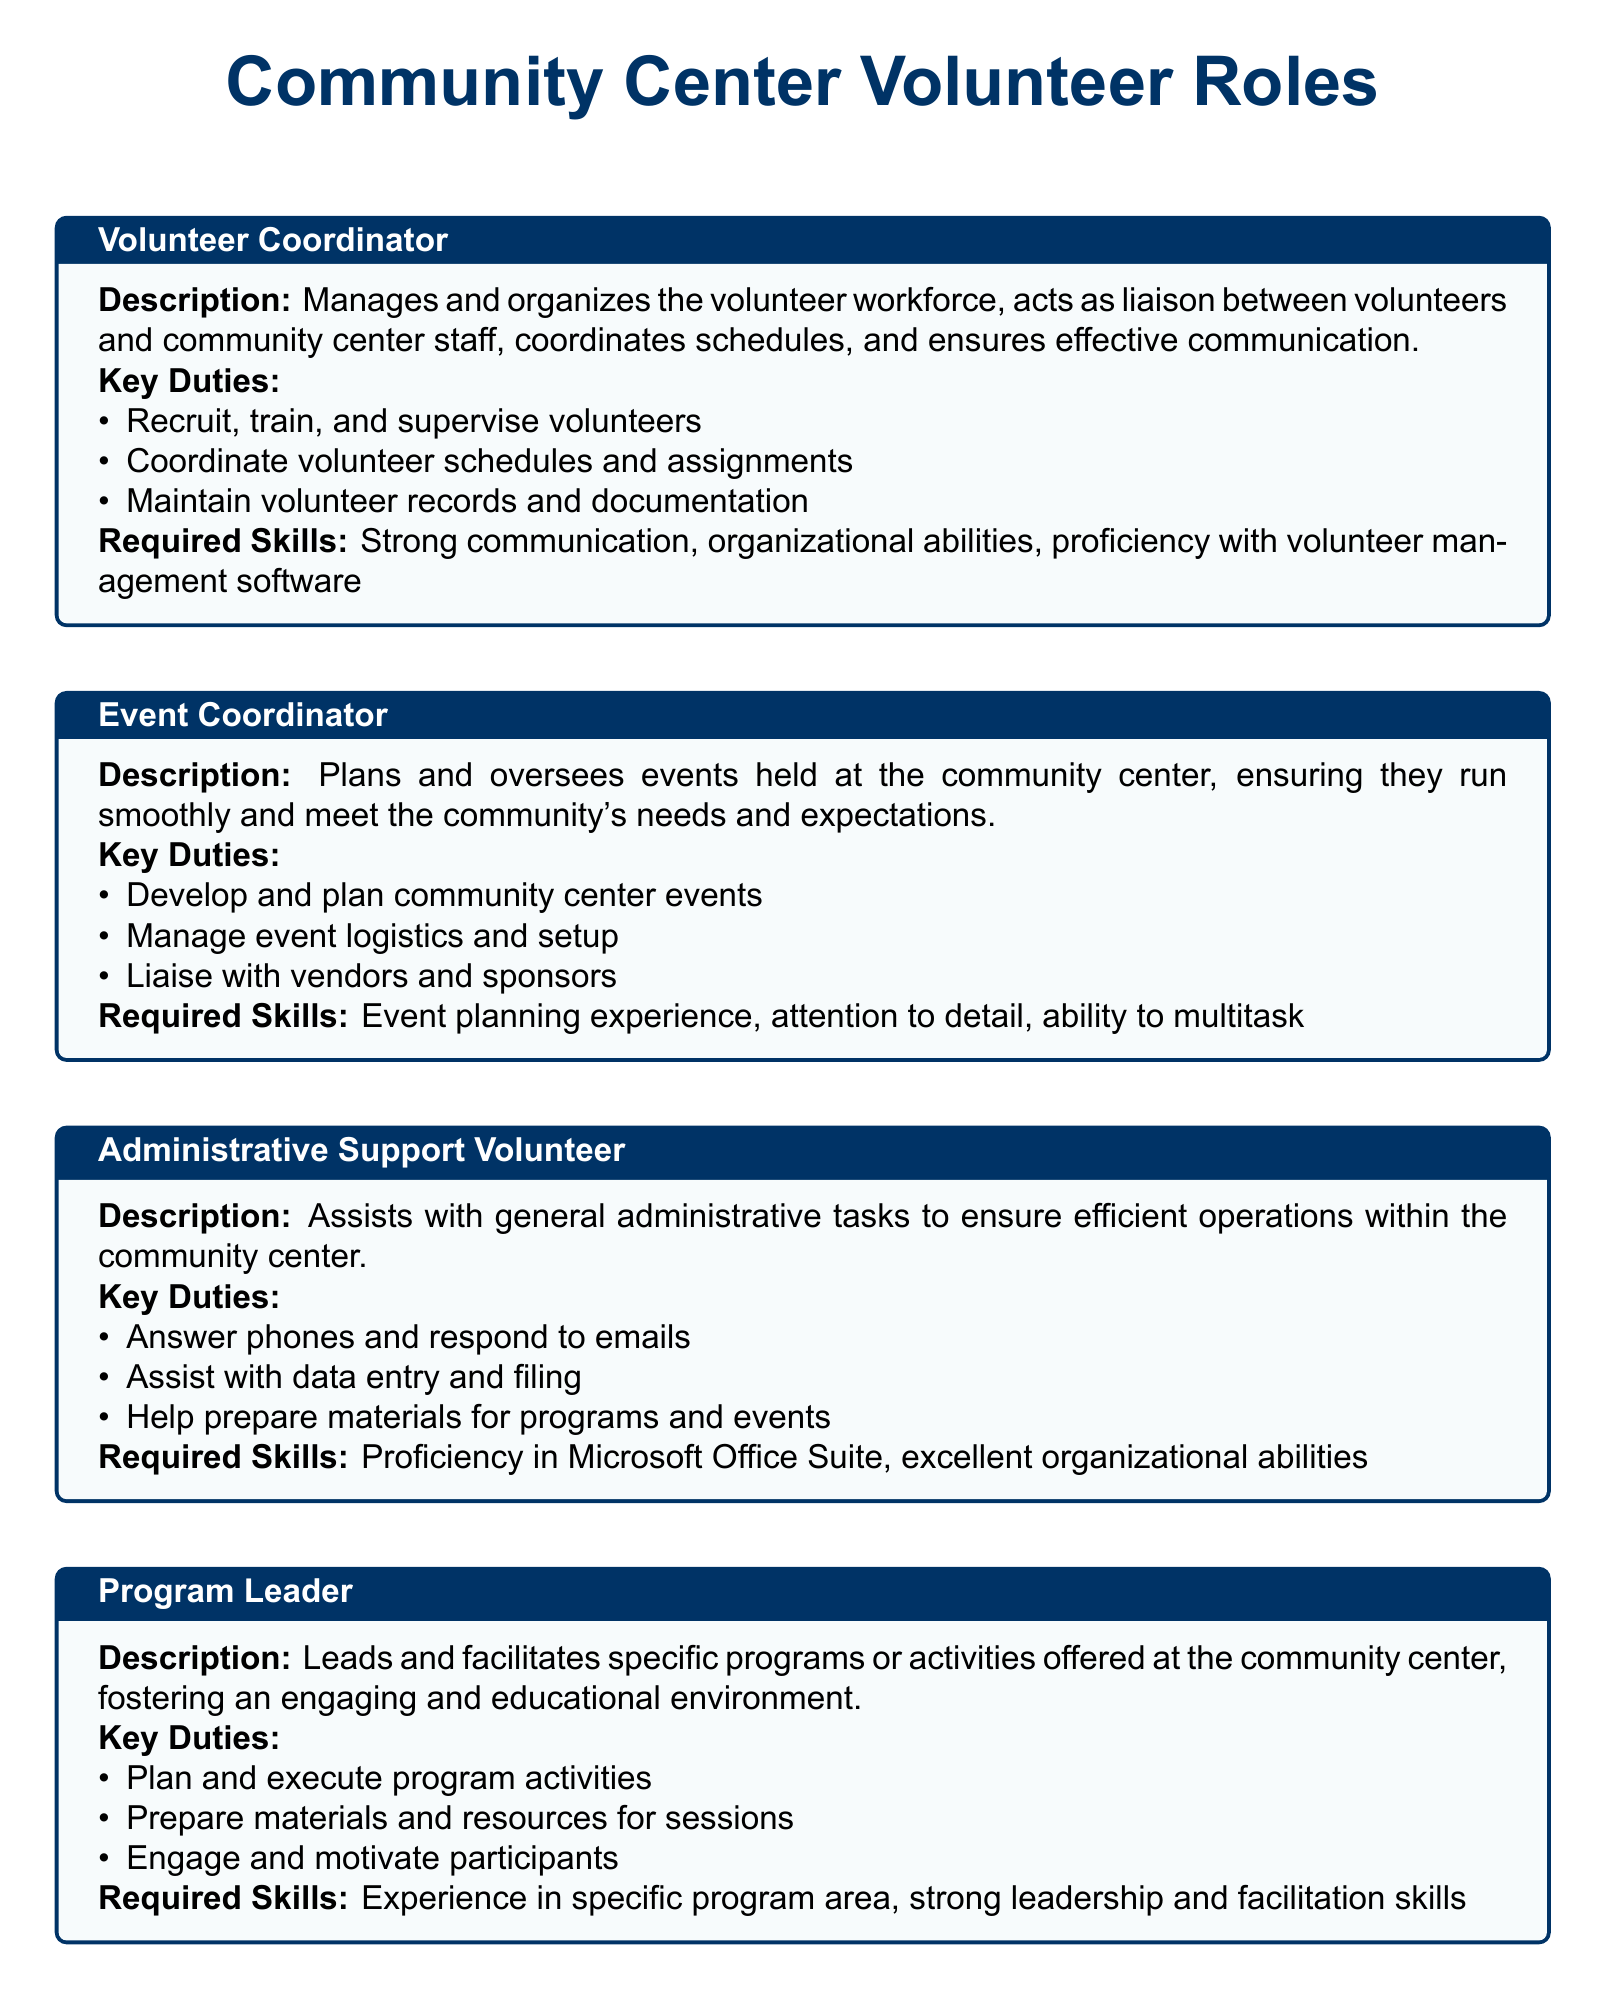what is the title of the document? The title of the document is stated at the top as "Community Center Volunteer Roles."
Answer: Community Center Volunteer Roles who is responsible for managing the volunteer workforce? The document specifies that the Volunteer Coordinator manages the volunteer workforce.
Answer: Volunteer Coordinator how many key duties are listed for an Event Coordinator? The Event Coordinator has three key duties outlined in the document.
Answer: 3 what are the required skills for an Administrative Support Volunteer? The required skills for an Administrative Support Volunteer include proficiency in Microsoft Office Suite and excellent organizational abilities.
Answer: Proficiency in Microsoft Office Suite, excellent organizational abilities which role is responsible for maintaining the cleanliness of the community center? The role that helps maintain the cleanliness and functionality of the community center facilities is the Facilities Maintenance Volunteer.
Answer: Facilities Maintenance Volunteer which volunteer role involves liaising with vendors? The Event Coordinator is the volunteer role that involves liaising with vendors and sponsors.
Answer: Event Coordinator what is one of the required skills for a Program Leader? A required skill for a Program Leader is strong leadership and facilitation skills.
Answer: Strong leadership and facilitation skills how does the Volunteer Coordinator assist volunteers? The Volunteer Coordinator recruits, trains, and supervises volunteers.
Answer: Recruit, train, and supervise volunteers 